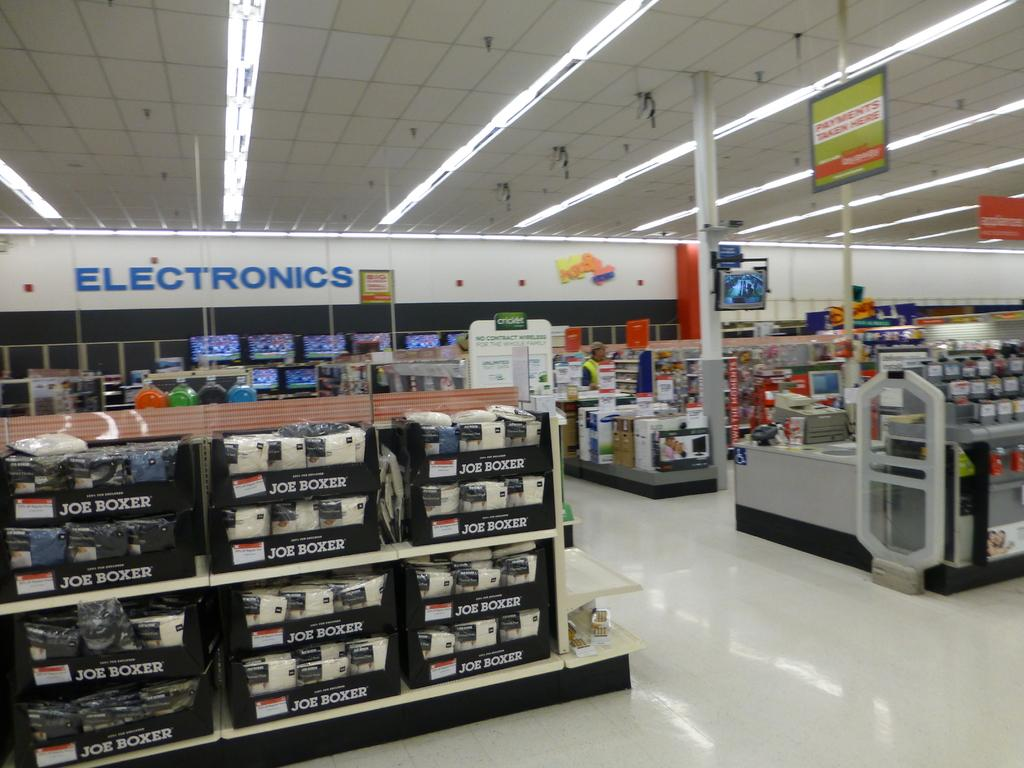<image>
Offer a succinct explanation of the picture presented. The Electronics section of a supermarket with TVs on the display. 